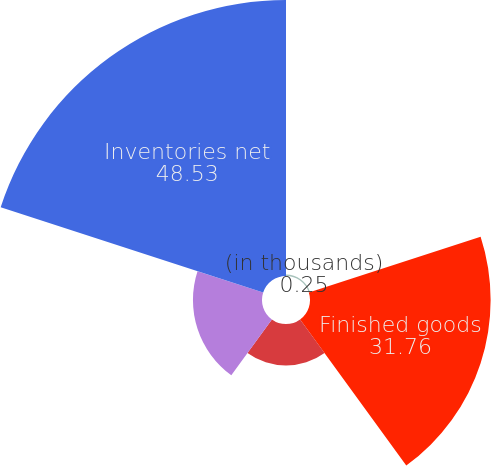Convert chart to OTSL. <chart><loc_0><loc_0><loc_500><loc_500><pie_chart><fcel>(in thousands)<fcel>Finished goods<fcel>Work-in-process<fcel>Raw materials and supplies<fcel>Inventories net<nl><fcel>0.25%<fcel>31.76%<fcel>7.31%<fcel>12.14%<fcel>48.53%<nl></chart> 